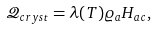Convert formula to latex. <formula><loc_0><loc_0><loc_500><loc_500>\mathcal { Q } _ { c r y s t } = \lambda ( T ) \varrho _ { a } H _ { a c } ,</formula> 